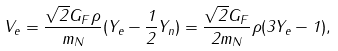<formula> <loc_0><loc_0><loc_500><loc_500>V _ { e } = \frac { \sqrt { 2 } G _ { F } \rho } { m _ { N } } ( Y _ { e } - \frac { 1 } { 2 } Y _ { n } ) = \frac { \sqrt { 2 } G _ { F } } { 2 m _ { N } } \rho ( 3 Y _ { e } - 1 ) ,</formula> 